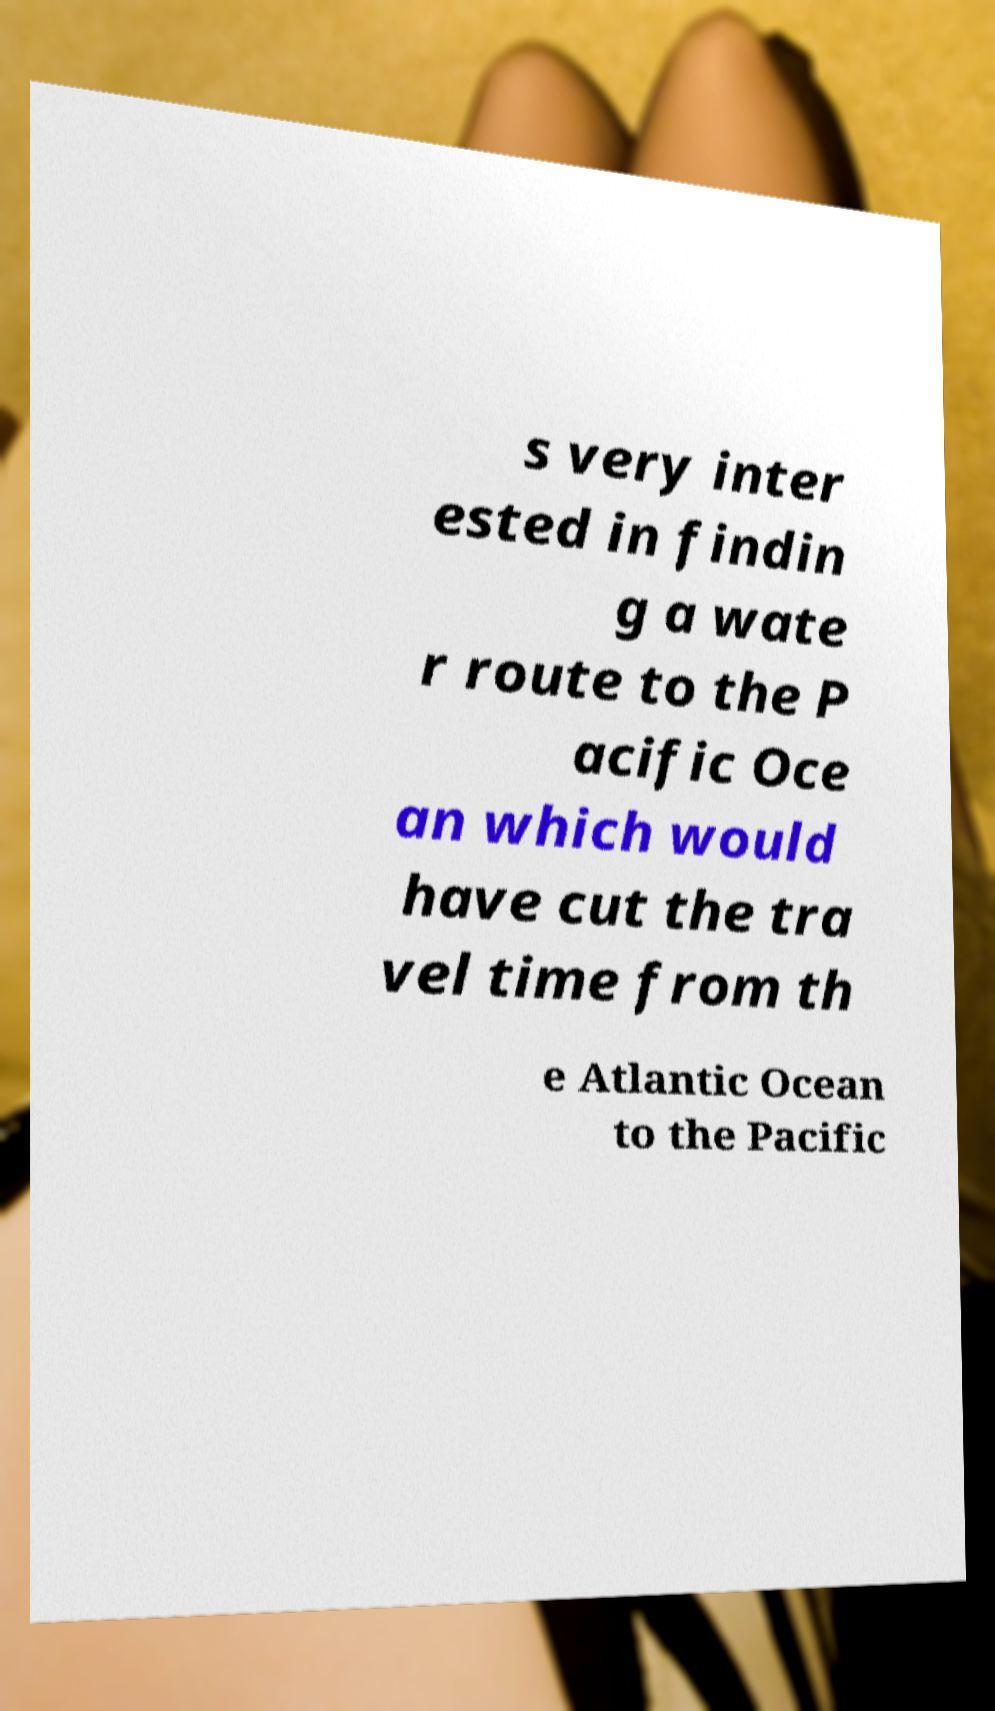Can you accurately transcribe the text from the provided image for me? s very inter ested in findin g a wate r route to the P acific Oce an which would have cut the tra vel time from th e Atlantic Ocean to the Pacific 